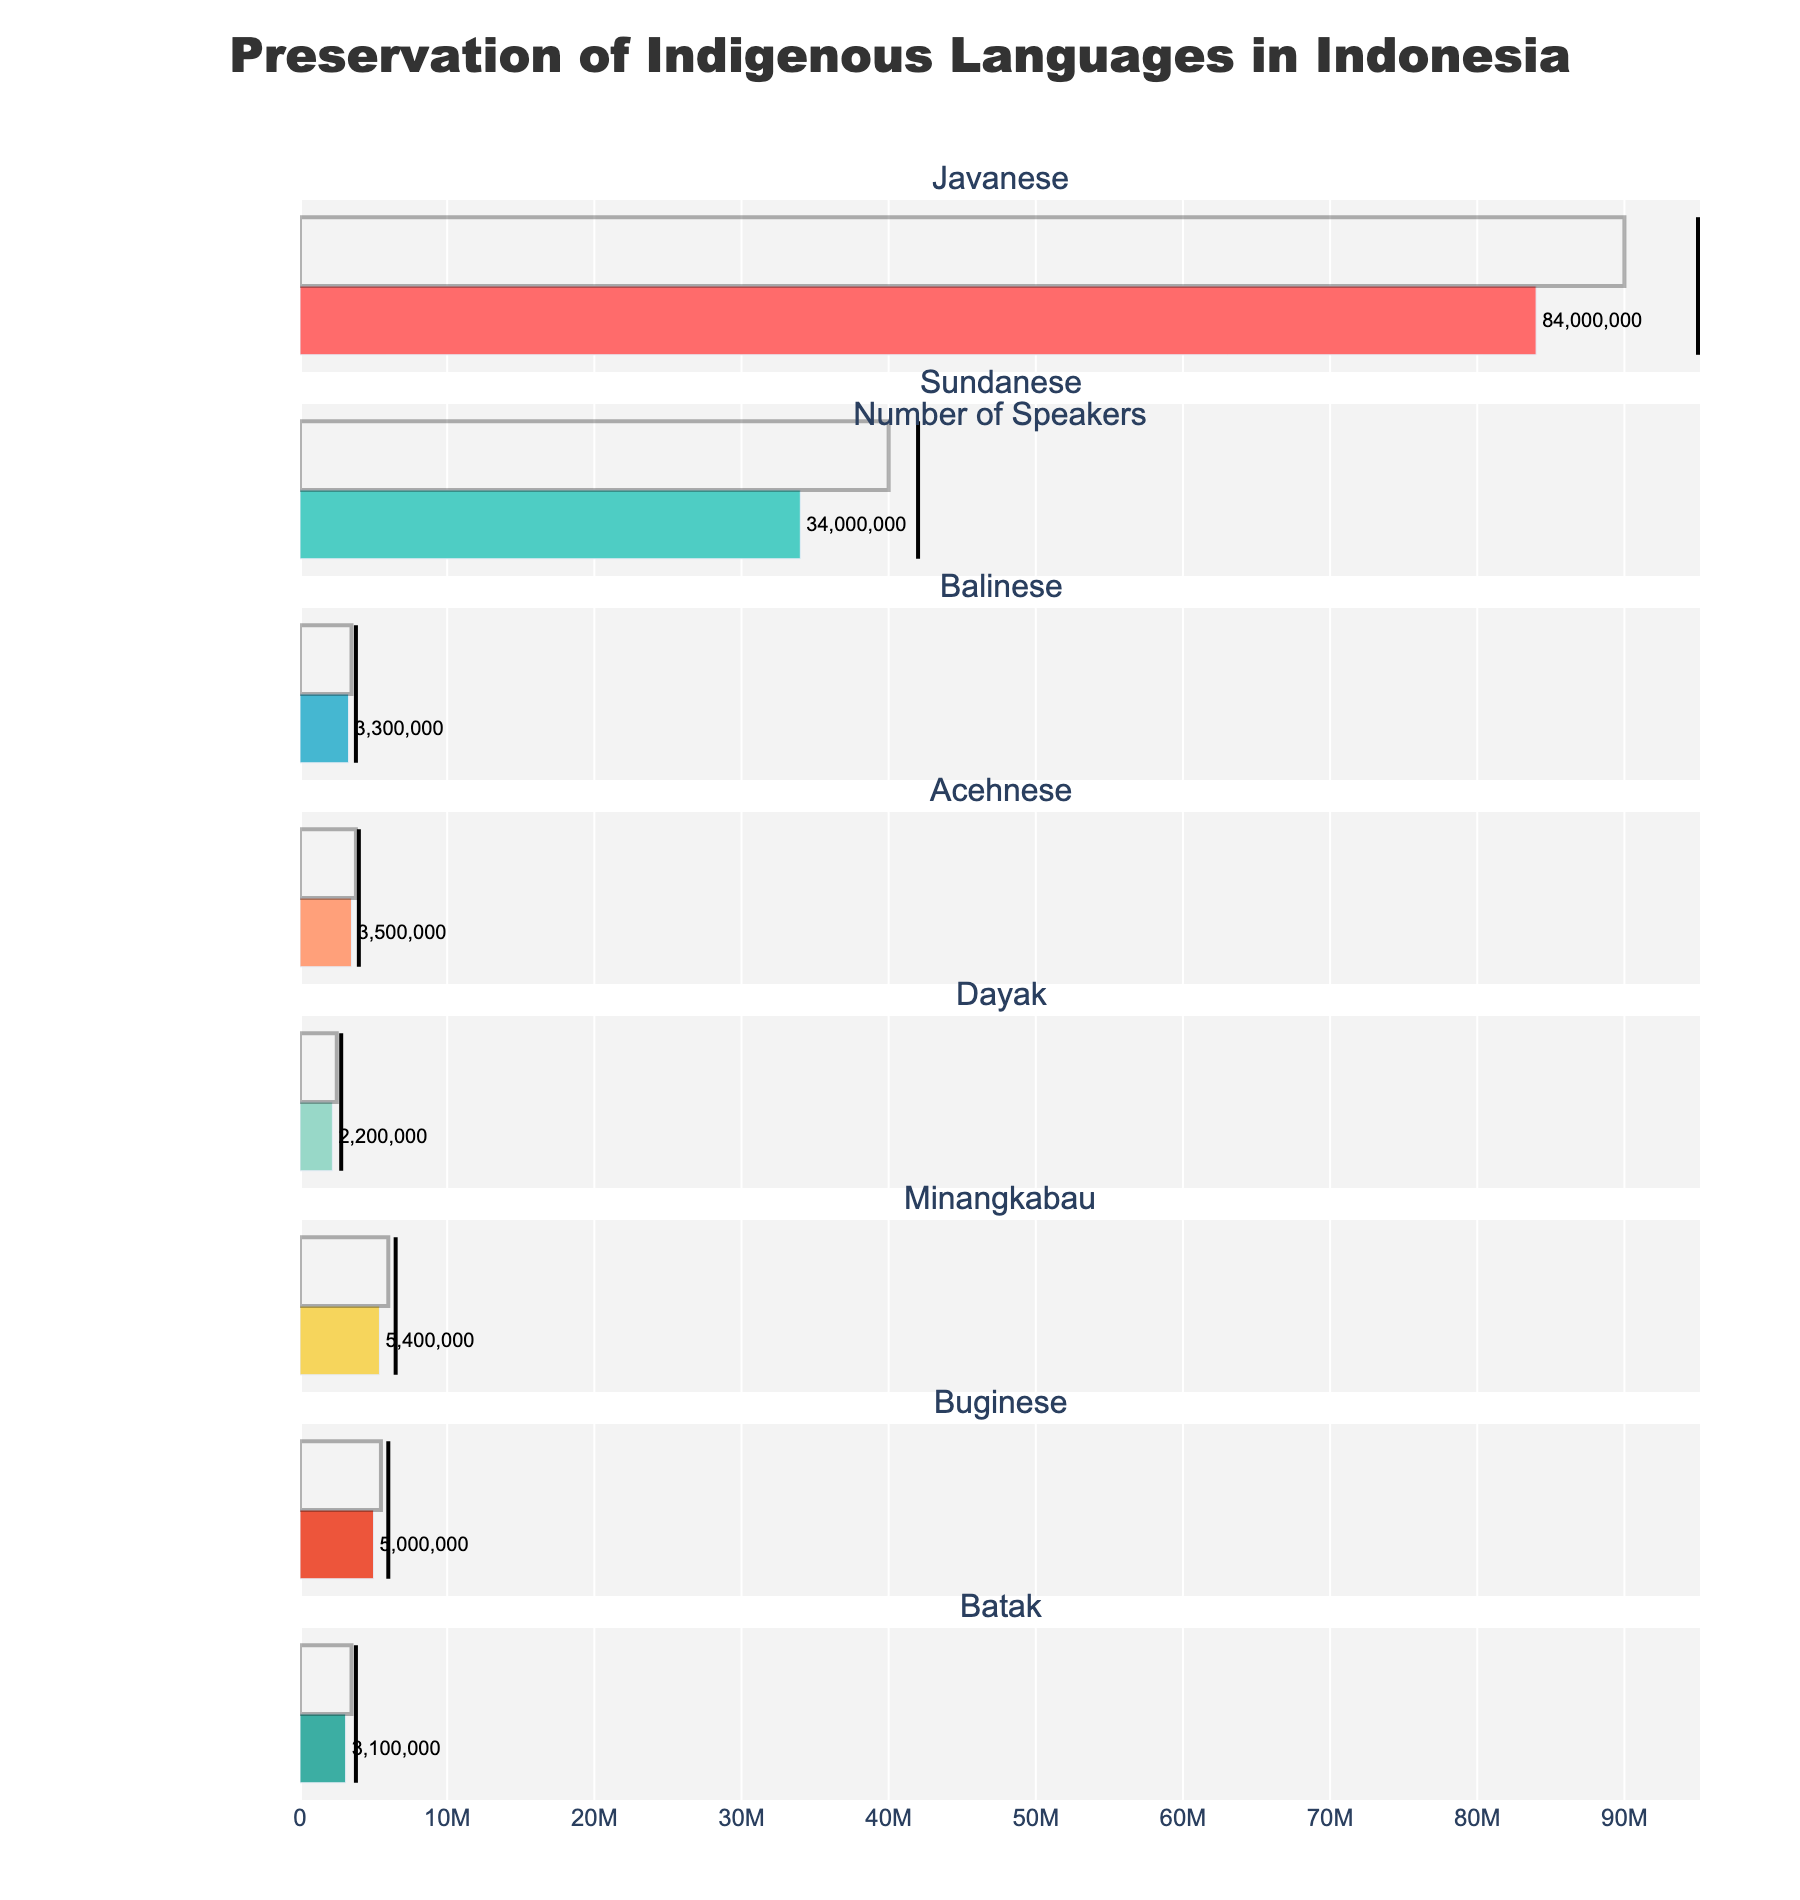What is the title of the figure? The title of the figure is usually located at the top center of the plot. In this case, it's "Preservation of Indigenous Languages in Indonesia".
Answer: Preservation of Indigenous Languages in Indonesia Which indigenous language has the highest number of actual speakers? To find the highest number of actual speakers, scan the actual speaker bars and identify the one with the longest bar. In this figure, it's the Javanese language.
Answer: Javanese Which language's actual number of speakers is closest to its target? To answer this, compare the actual and target speaker values for each language and identify the one with the smallest difference. The Balinese language has 3,300,000 actual speakers, very close to its target of 3,500,000.
Answer: Balinese Which language exceeds its comparative measure the most? Look at the distance between the actual speaker bars and the comparative measure lines. Javanese exceeds its comparative measure the most because the bar for actual speakers surpasses the comparative line by the largest margin.
Answer: Javanese How many languages have their actual number of speakers below the target? Count the number of languages where the actual speaker bar is shorter than the target speaker bar. Based on the visual inspection, all languages have their actual speakers below the target. So there are 8 languages.
Answer: 8 Which language has the smallest actual number of speakers? Identify the shortest bar representing actual speakers. In this figure, the Dayak language has the smallest number of actual speakers.
Answer: Dayak For the language with the largest difference between actual and target speakers, what's the difference? Javanese has the largest difference. Actual speakers are 84,000,000 and target speakers are 90,000,000. The difference is 90,000,000 - 84,000,000 = 6,000,000.
Answer: 6,000,000 Is any language close to reaching its comparative measure? Check the closest actual speaker bar to the comparative measure line. Balinese and Batak languages are close, but Batak is the closest with 3,800,000 comparative and 3,100,000 actual speakers.
Answer: Batak 